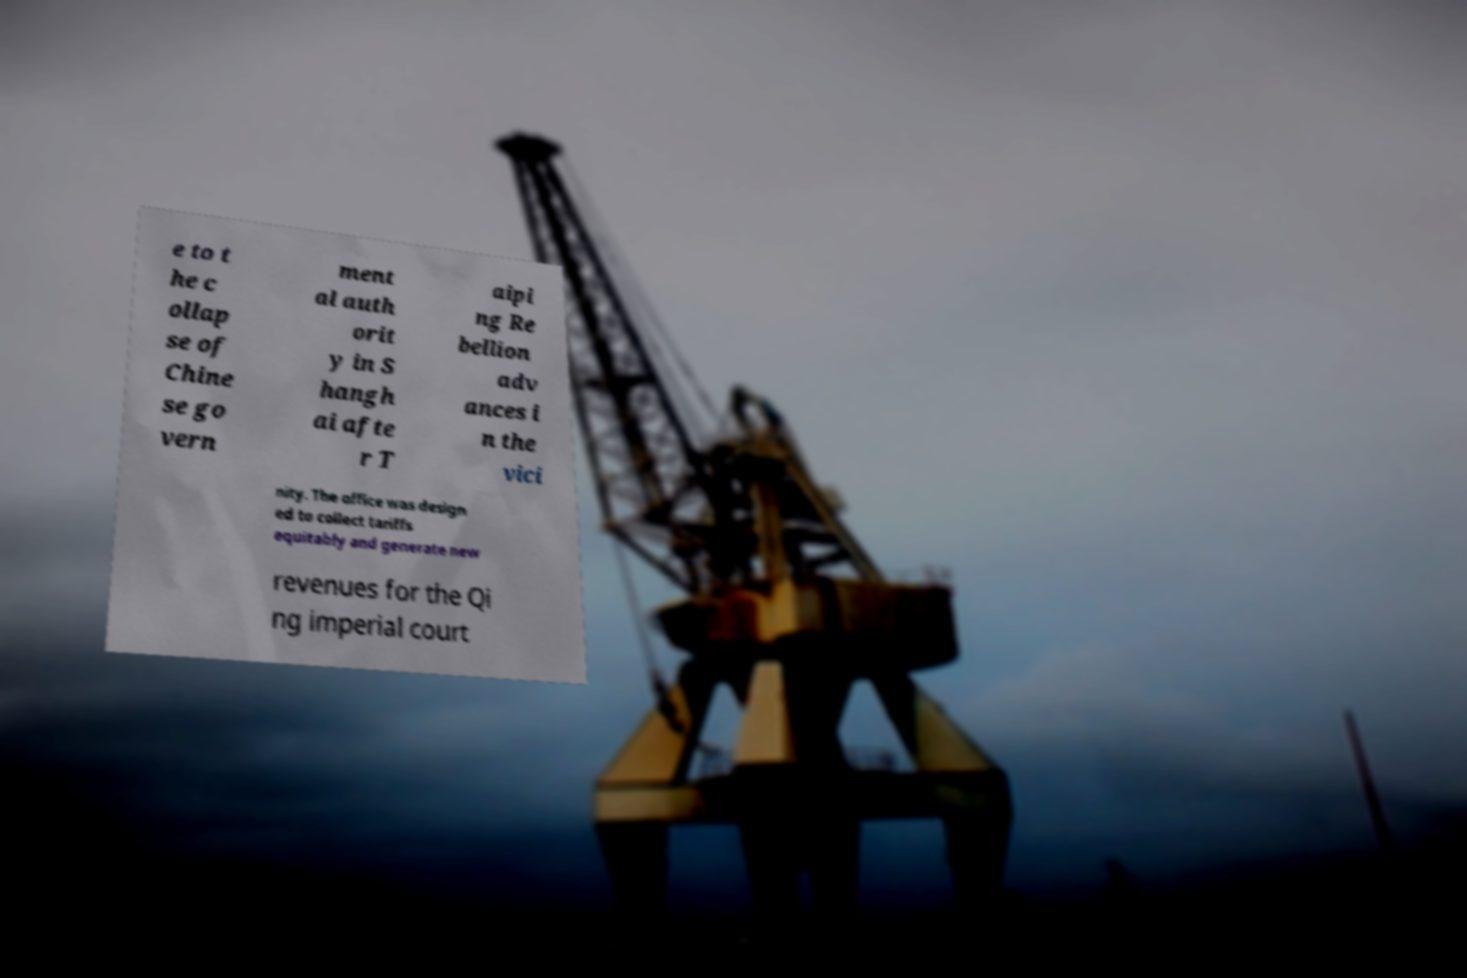For documentation purposes, I need the text within this image transcribed. Could you provide that? e to t he c ollap se of Chine se go vern ment al auth orit y in S hangh ai afte r T aipi ng Re bellion adv ances i n the vici nity. The office was design ed to collect tariffs equitably and generate new revenues for the Qi ng imperial court 